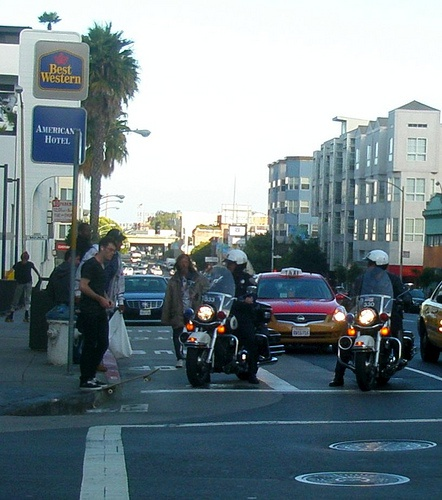Describe the objects in this image and their specific colors. I can see motorcycle in white, black, blue, gray, and darkblue tones, motorcycle in white, black, darkblue, blue, and gray tones, car in white, blue, black, gray, and maroon tones, people in white, black, and gray tones, and people in white, black, darkblue, blue, and darkgray tones in this image. 